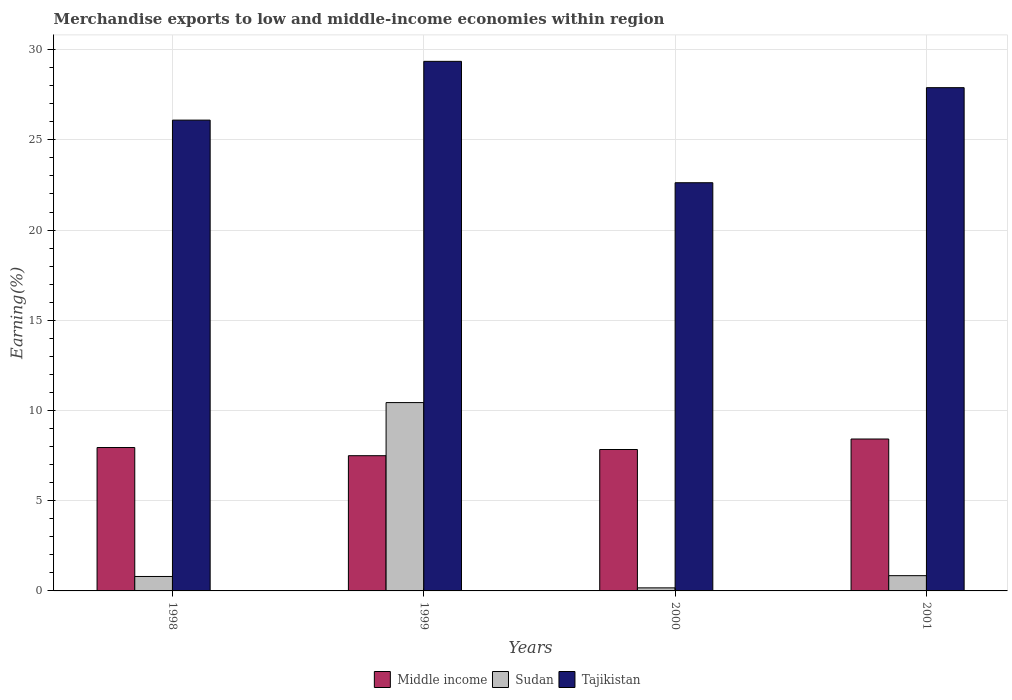How many different coloured bars are there?
Your answer should be very brief. 3. How many groups of bars are there?
Provide a succinct answer. 4. Are the number of bars per tick equal to the number of legend labels?
Your response must be concise. Yes. How many bars are there on the 4th tick from the right?
Make the answer very short. 3. What is the percentage of amount earned from merchandise exports in Sudan in 2000?
Keep it short and to the point. 0.17. Across all years, what is the maximum percentage of amount earned from merchandise exports in Tajikistan?
Your response must be concise. 29.35. Across all years, what is the minimum percentage of amount earned from merchandise exports in Middle income?
Provide a short and direct response. 7.49. What is the total percentage of amount earned from merchandise exports in Tajikistan in the graph?
Provide a short and direct response. 105.96. What is the difference between the percentage of amount earned from merchandise exports in Sudan in 1998 and that in 2001?
Your answer should be compact. -0.04. What is the difference between the percentage of amount earned from merchandise exports in Sudan in 2000 and the percentage of amount earned from merchandise exports in Tajikistan in 2001?
Provide a succinct answer. -27.72. What is the average percentage of amount earned from merchandise exports in Middle income per year?
Make the answer very short. 7.92. In the year 2001, what is the difference between the percentage of amount earned from merchandise exports in Tajikistan and percentage of amount earned from merchandise exports in Sudan?
Your answer should be very brief. 27.05. In how many years, is the percentage of amount earned from merchandise exports in Middle income greater than 29 %?
Provide a succinct answer. 0. What is the ratio of the percentage of amount earned from merchandise exports in Sudan in 1998 to that in 2001?
Your response must be concise. 0.95. Is the percentage of amount earned from merchandise exports in Sudan in 2000 less than that in 2001?
Ensure brevity in your answer.  Yes. Is the difference between the percentage of amount earned from merchandise exports in Tajikistan in 2000 and 2001 greater than the difference between the percentage of amount earned from merchandise exports in Sudan in 2000 and 2001?
Keep it short and to the point. No. What is the difference between the highest and the second highest percentage of amount earned from merchandise exports in Sudan?
Ensure brevity in your answer.  9.59. What is the difference between the highest and the lowest percentage of amount earned from merchandise exports in Sudan?
Your answer should be compact. 10.27. Is the sum of the percentage of amount earned from merchandise exports in Tajikistan in 1998 and 1999 greater than the maximum percentage of amount earned from merchandise exports in Sudan across all years?
Keep it short and to the point. Yes. What does the 2nd bar from the left in 2000 represents?
Ensure brevity in your answer.  Sudan. What does the 1st bar from the right in 1998 represents?
Your answer should be very brief. Tajikistan. How many bars are there?
Offer a terse response. 12. How many years are there in the graph?
Offer a terse response. 4. What is the difference between two consecutive major ticks on the Y-axis?
Keep it short and to the point. 5. How many legend labels are there?
Offer a very short reply. 3. What is the title of the graph?
Your response must be concise. Merchandise exports to low and middle-income economies within region. Does "Monaco" appear as one of the legend labels in the graph?
Your answer should be very brief. No. What is the label or title of the Y-axis?
Provide a short and direct response. Earning(%). What is the Earning(%) in Middle income in 1998?
Offer a very short reply. 7.95. What is the Earning(%) of Sudan in 1998?
Your answer should be compact. 0.8. What is the Earning(%) in Tajikistan in 1998?
Give a very brief answer. 26.09. What is the Earning(%) in Middle income in 1999?
Offer a terse response. 7.49. What is the Earning(%) in Sudan in 1999?
Your response must be concise. 10.44. What is the Earning(%) in Tajikistan in 1999?
Give a very brief answer. 29.35. What is the Earning(%) in Middle income in 2000?
Offer a very short reply. 7.84. What is the Earning(%) of Sudan in 2000?
Ensure brevity in your answer.  0.17. What is the Earning(%) in Tajikistan in 2000?
Your response must be concise. 22.62. What is the Earning(%) of Middle income in 2001?
Your answer should be very brief. 8.42. What is the Earning(%) of Sudan in 2001?
Provide a succinct answer. 0.85. What is the Earning(%) in Tajikistan in 2001?
Provide a succinct answer. 27.89. Across all years, what is the maximum Earning(%) in Middle income?
Your answer should be very brief. 8.42. Across all years, what is the maximum Earning(%) in Sudan?
Give a very brief answer. 10.44. Across all years, what is the maximum Earning(%) in Tajikistan?
Offer a terse response. 29.35. Across all years, what is the minimum Earning(%) of Middle income?
Offer a very short reply. 7.49. Across all years, what is the minimum Earning(%) in Sudan?
Make the answer very short. 0.17. Across all years, what is the minimum Earning(%) of Tajikistan?
Give a very brief answer. 22.62. What is the total Earning(%) of Middle income in the graph?
Your answer should be compact. 31.7. What is the total Earning(%) in Sudan in the graph?
Make the answer very short. 12.25. What is the total Earning(%) of Tajikistan in the graph?
Offer a very short reply. 105.96. What is the difference between the Earning(%) in Middle income in 1998 and that in 1999?
Give a very brief answer. 0.45. What is the difference between the Earning(%) of Sudan in 1998 and that in 1999?
Offer a very short reply. -9.64. What is the difference between the Earning(%) of Tajikistan in 1998 and that in 1999?
Your answer should be compact. -3.26. What is the difference between the Earning(%) in Middle income in 1998 and that in 2000?
Your answer should be very brief. 0.11. What is the difference between the Earning(%) in Sudan in 1998 and that in 2000?
Your response must be concise. 0.63. What is the difference between the Earning(%) in Tajikistan in 1998 and that in 2000?
Your answer should be very brief. 3.47. What is the difference between the Earning(%) of Middle income in 1998 and that in 2001?
Make the answer very short. -0.47. What is the difference between the Earning(%) of Sudan in 1998 and that in 2001?
Offer a terse response. -0.04. What is the difference between the Earning(%) in Tajikistan in 1998 and that in 2001?
Offer a terse response. -1.8. What is the difference between the Earning(%) in Middle income in 1999 and that in 2000?
Provide a succinct answer. -0.34. What is the difference between the Earning(%) in Sudan in 1999 and that in 2000?
Your response must be concise. 10.27. What is the difference between the Earning(%) of Tajikistan in 1999 and that in 2000?
Your answer should be compact. 6.73. What is the difference between the Earning(%) in Middle income in 1999 and that in 2001?
Give a very brief answer. -0.92. What is the difference between the Earning(%) of Sudan in 1999 and that in 2001?
Offer a terse response. 9.59. What is the difference between the Earning(%) in Tajikistan in 1999 and that in 2001?
Offer a terse response. 1.46. What is the difference between the Earning(%) in Middle income in 2000 and that in 2001?
Your response must be concise. -0.58. What is the difference between the Earning(%) of Sudan in 2000 and that in 2001?
Ensure brevity in your answer.  -0.68. What is the difference between the Earning(%) in Tajikistan in 2000 and that in 2001?
Offer a very short reply. -5.27. What is the difference between the Earning(%) of Middle income in 1998 and the Earning(%) of Sudan in 1999?
Give a very brief answer. -2.49. What is the difference between the Earning(%) of Middle income in 1998 and the Earning(%) of Tajikistan in 1999?
Offer a very short reply. -21.4. What is the difference between the Earning(%) of Sudan in 1998 and the Earning(%) of Tajikistan in 1999?
Your answer should be compact. -28.55. What is the difference between the Earning(%) in Middle income in 1998 and the Earning(%) in Sudan in 2000?
Offer a very short reply. 7.78. What is the difference between the Earning(%) of Middle income in 1998 and the Earning(%) of Tajikistan in 2000?
Your answer should be very brief. -14.68. What is the difference between the Earning(%) in Sudan in 1998 and the Earning(%) in Tajikistan in 2000?
Make the answer very short. -21.82. What is the difference between the Earning(%) in Middle income in 1998 and the Earning(%) in Sudan in 2001?
Provide a succinct answer. 7.1. What is the difference between the Earning(%) in Middle income in 1998 and the Earning(%) in Tajikistan in 2001?
Ensure brevity in your answer.  -19.95. What is the difference between the Earning(%) in Sudan in 1998 and the Earning(%) in Tajikistan in 2001?
Your response must be concise. -27.09. What is the difference between the Earning(%) of Middle income in 1999 and the Earning(%) of Sudan in 2000?
Make the answer very short. 7.33. What is the difference between the Earning(%) of Middle income in 1999 and the Earning(%) of Tajikistan in 2000?
Make the answer very short. -15.13. What is the difference between the Earning(%) in Sudan in 1999 and the Earning(%) in Tajikistan in 2000?
Ensure brevity in your answer.  -12.19. What is the difference between the Earning(%) of Middle income in 1999 and the Earning(%) of Sudan in 2001?
Ensure brevity in your answer.  6.65. What is the difference between the Earning(%) of Middle income in 1999 and the Earning(%) of Tajikistan in 2001?
Offer a very short reply. -20.4. What is the difference between the Earning(%) of Sudan in 1999 and the Earning(%) of Tajikistan in 2001?
Ensure brevity in your answer.  -17.45. What is the difference between the Earning(%) of Middle income in 2000 and the Earning(%) of Sudan in 2001?
Ensure brevity in your answer.  6.99. What is the difference between the Earning(%) in Middle income in 2000 and the Earning(%) in Tajikistan in 2001?
Your answer should be very brief. -20.05. What is the difference between the Earning(%) in Sudan in 2000 and the Earning(%) in Tajikistan in 2001?
Ensure brevity in your answer.  -27.72. What is the average Earning(%) of Middle income per year?
Provide a short and direct response. 7.92. What is the average Earning(%) in Sudan per year?
Give a very brief answer. 3.06. What is the average Earning(%) in Tajikistan per year?
Your response must be concise. 26.49. In the year 1998, what is the difference between the Earning(%) of Middle income and Earning(%) of Sudan?
Your answer should be compact. 7.15. In the year 1998, what is the difference between the Earning(%) of Middle income and Earning(%) of Tajikistan?
Your answer should be very brief. -18.15. In the year 1998, what is the difference between the Earning(%) of Sudan and Earning(%) of Tajikistan?
Provide a succinct answer. -25.29. In the year 1999, what is the difference between the Earning(%) of Middle income and Earning(%) of Sudan?
Your answer should be very brief. -2.94. In the year 1999, what is the difference between the Earning(%) of Middle income and Earning(%) of Tajikistan?
Your answer should be very brief. -21.86. In the year 1999, what is the difference between the Earning(%) in Sudan and Earning(%) in Tajikistan?
Provide a short and direct response. -18.91. In the year 2000, what is the difference between the Earning(%) in Middle income and Earning(%) in Sudan?
Give a very brief answer. 7.67. In the year 2000, what is the difference between the Earning(%) of Middle income and Earning(%) of Tajikistan?
Your response must be concise. -14.79. In the year 2000, what is the difference between the Earning(%) of Sudan and Earning(%) of Tajikistan?
Ensure brevity in your answer.  -22.45. In the year 2001, what is the difference between the Earning(%) in Middle income and Earning(%) in Sudan?
Give a very brief answer. 7.57. In the year 2001, what is the difference between the Earning(%) of Middle income and Earning(%) of Tajikistan?
Give a very brief answer. -19.47. In the year 2001, what is the difference between the Earning(%) of Sudan and Earning(%) of Tajikistan?
Ensure brevity in your answer.  -27.05. What is the ratio of the Earning(%) in Middle income in 1998 to that in 1999?
Your answer should be compact. 1.06. What is the ratio of the Earning(%) in Sudan in 1998 to that in 1999?
Your answer should be very brief. 0.08. What is the ratio of the Earning(%) of Tajikistan in 1998 to that in 1999?
Provide a short and direct response. 0.89. What is the ratio of the Earning(%) of Middle income in 1998 to that in 2000?
Provide a succinct answer. 1.01. What is the ratio of the Earning(%) of Sudan in 1998 to that in 2000?
Provide a succinct answer. 4.73. What is the ratio of the Earning(%) of Tajikistan in 1998 to that in 2000?
Keep it short and to the point. 1.15. What is the ratio of the Earning(%) of Middle income in 1998 to that in 2001?
Offer a terse response. 0.94. What is the ratio of the Earning(%) of Sudan in 1998 to that in 2001?
Your answer should be very brief. 0.95. What is the ratio of the Earning(%) in Tajikistan in 1998 to that in 2001?
Your answer should be very brief. 0.94. What is the ratio of the Earning(%) in Middle income in 1999 to that in 2000?
Make the answer very short. 0.96. What is the ratio of the Earning(%) in Sudan in 1999 to that in 2000?
Give a very brief answer. 61.7. What is the ratio of the Earning(%) of Tajikistan in 1999 to that in 2000?
Keep it short and to the point. 1.3. What is the ratio of the Earning(%) of Middle income in 1999 to that in 2001?
Ensure brevity in your answer.  0.89. What is the ratio of the Earning(%) of Sudan in 1999 to that in 2001?
Make the answer very short. 12.34. What is the ratio of the Earning(%) of Tajikistan in 1999 to that in 2001?
Provide a short and direct response. 1.05. What is the ratio of the Earning(%) of Middle income in 2000 to that in 2001?
Provide a short and direct response. 0.93. What is the ratio of the Earning(%) in Sudan in 2000 to that in 2001?
Your response must be concise. 0.2. What is the ratio of the Earning(%) of Tajikistan in 2000 to that in 2001?
Offer a very short reply. 0.81. What is the difference between the highest and the second highest Earning(%) of Middle income?
Ensure brevity in your answer.  0.47. What is the difference between the highest and the second highest Earning(%) of Sudan?
Make the answer very short. 9.59. What is the difference between the highest and the second highest Earning(%) in Tajikistan?
Your answer should be compact. 1.46. What is the difference between the highest and the lowest Earning(%) in Middle income?
Your answer should be very brief. 0.92. What is the difference between the highest and the lowest Earning(%) of Sudan?
Keep it short and to the point. 10.27. What is the difference between the highest and the lowest Earning(%) of Tajikistan?
Your response must be concise. 6.73. 